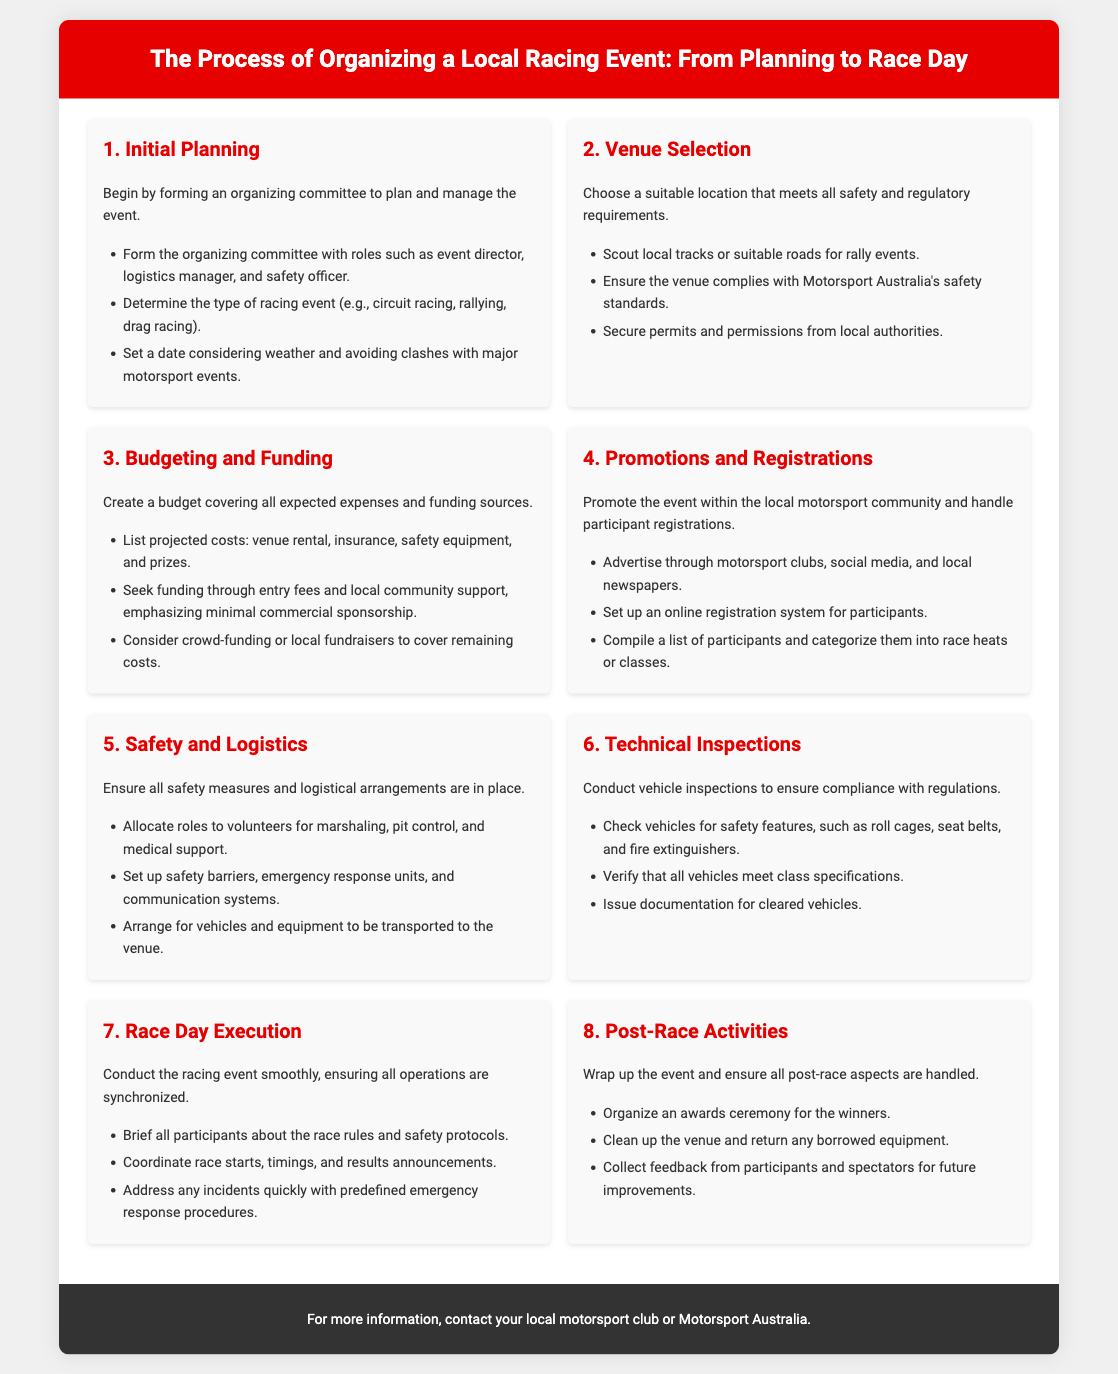what is the first step in organizing a local racing event? The first step is to form an organizing committee to plan and manage the event.
Answer: Initial Planning what role is responsible for managing logistics? The role responsible for managing logistics is mentioned in the initial planning step.
Answer: Logistics Manager which type of racing can be organized according to the document? The document mentions circuit racing, rallying, and drag racing as possible types of racing events.
Answer: Circuit racing, rallying, drag racing what should be ensured when selecting a venue? The venue must comply with Motorsport Australia's safety standards.
Answer: Safety standards how many roles should be allocated to volunteers for race day? The specific roles mentioned for volunteers include marshaling, pit control, and medical support, indicating multiple roles should be allocated.
Answer: Multiple roles what is one method mentioned for securing funding? The document suggests seeking funding through entry fees.
Answer: Entry fees what is required for vehicle inspections on race day? Vehicle inspections must ensure compliance with regulations, particularly checking safety features.
Answer: Compliance with regulations what is one of the post-race activities mentioned? An awards ceremony for the winners is highlighted as part of post-race activities.
Answer: Awards ceremony 